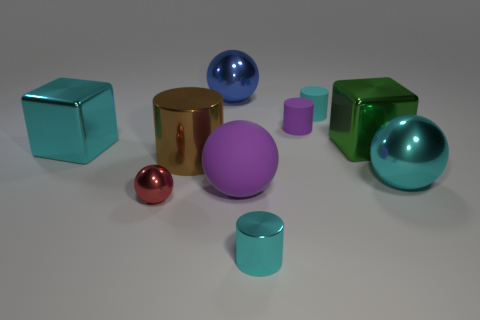Subtract all cylinders. How many objects are left? 6 Subtract all purple rubber cylinders. Subtract all things. How many objects are left? 8 Add 3 metallic cylinders. How many metallic cylinders are left? 5 Add 1 large purple shiny cylinders. How many large purple shiny cylinders exist? 1 Subtract 0 yellow balls. How many objects are left? 10 